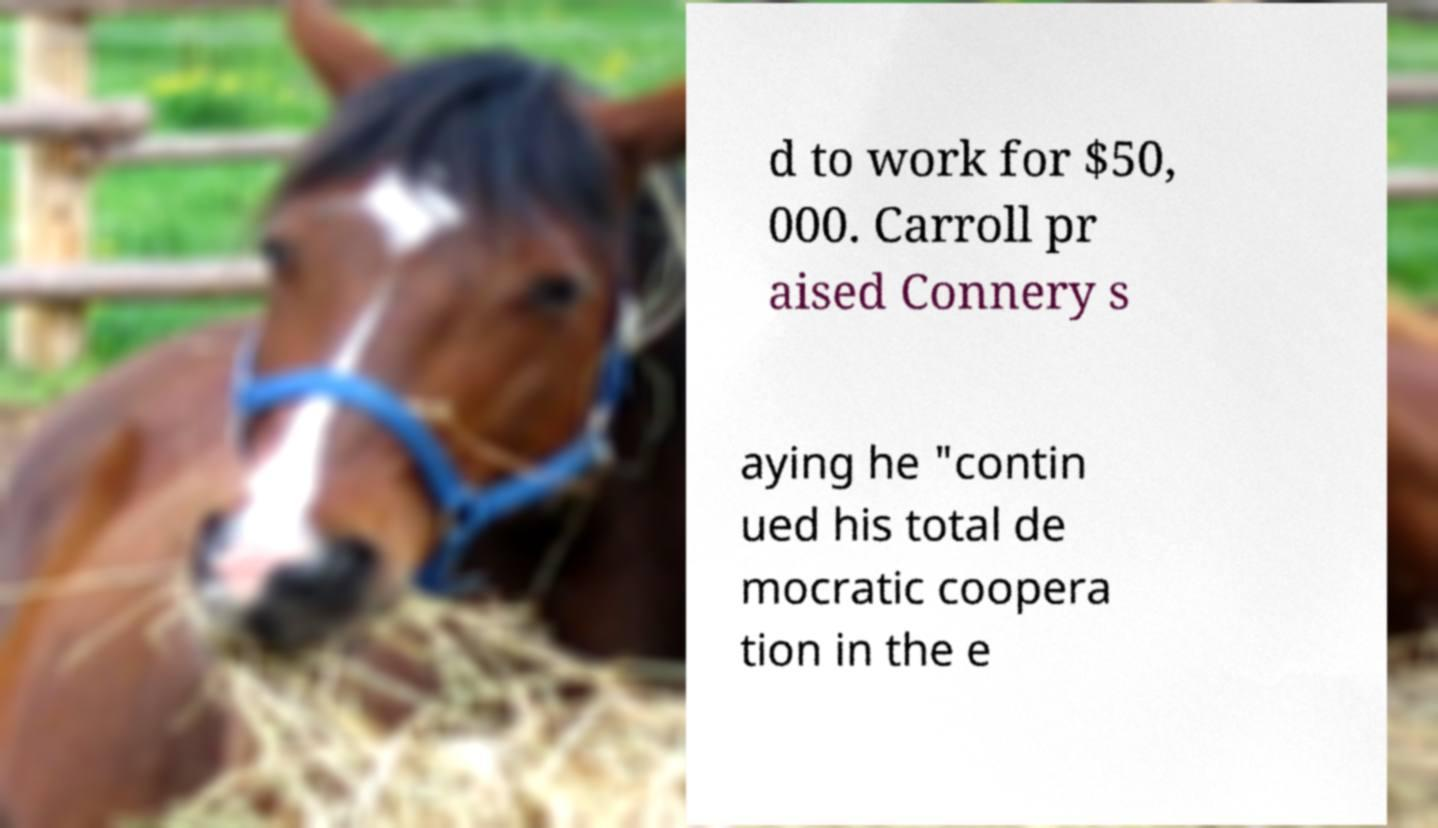Could you assist in decoding the text presented in this image and type it out clearly? d to work for $50, 000. Carroll pr aised Connery s aying he "contin ued his total de mocratic coopera tion in the e 